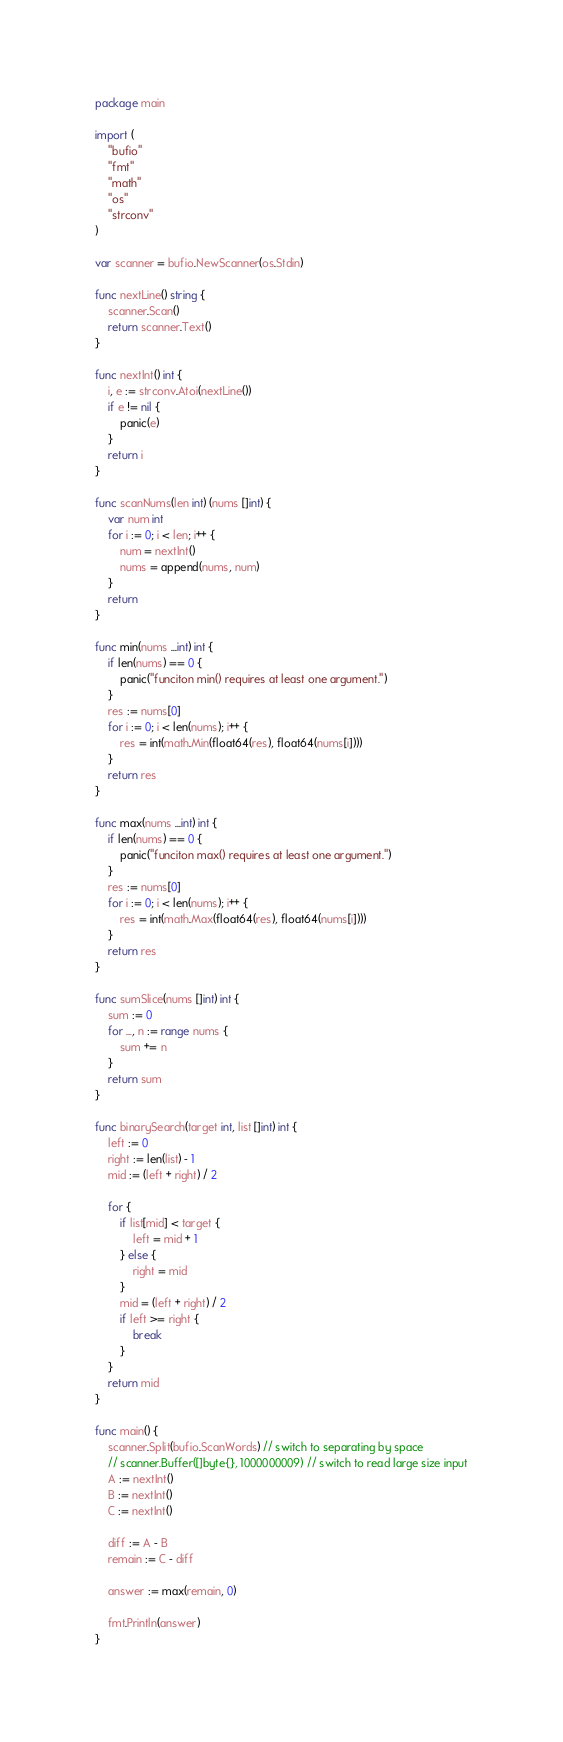<code> <loc_0><loc_0><loc_500><loc_500><_Go_>package main

import (
	"bufio"
	"fmt"
	"math"
	"os"
	"strconv"
)

var scanner = bufio.NewScanner(os.Stdin)

func nextLine() string {
	scanner.Scan()
	return scanner.Text()
}

func nextInt() int {
	i, e := strconv.Atoi(nextLine())
	if e != nil {
		panic(e)
	}
	return i
}

func scanNums(len int) (nums []int) {
	var num int
	for i := 0; i < len; i++ {
		num = nextInt()
		nums = append(nums, num)
	}
	return
}

func min(nums ...int) int {
	if len(nums) == 0 {
		panic("funciton min() requires at least one argument.")
	}
	res := nums[0]
	for i := 0; i < len(nums); i++ {
		res = int(math.Min(float64(res), float64(nums[i])))
	}
	return res
}

func max(nums ...int) int {
	if len(nums) == 0 {
		panic("funciton max() requires at least one argument.")
	}
	res := nums[0]
	for i := 0; i < len(nums); i++ {
		res = int(math.Max(float64(res), float64(nums[i])))
	}
	return res
}

func sumSlice(nums []int) int {
	sum := 0
	for _, n := range nums {
		sum += n
	}
	return sum
}

func binarySearch(target int, list []int) int {
	left := 0
	right := len(list) - 1
	mid := (left + right) / 2

	for {
		if list[mid] < target {
			left = mid + 1
		} else {
			right = mid
		}
		mid = (left + right) / 2
		if left >= right {
			break
		}
	}
	return mid
}

func main() {
	scanner.Split(bufio.ScanWords) // switch to separating by space
	// scanner.Buffer([]byte{}, 1000000009) // switch to read large size input
	A := nextInt()
	B := nextInt()
	C := nextInt()

	diff := A - B
	remain := C - diff

	answer := max(remain, 0)

	fmt.Println(answer)
}
</code> 